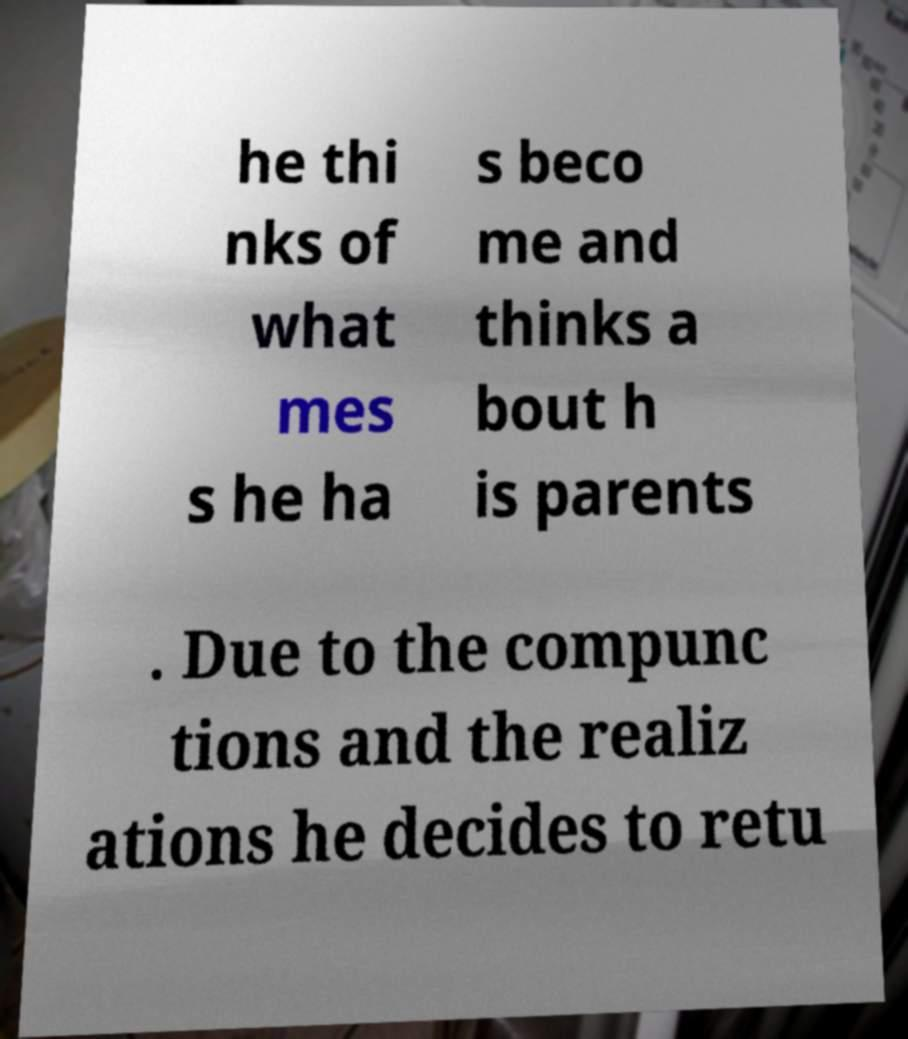Can you accurately transcribe the text from the provided image for me? he thi nks of what mes s he ha s beco me and thinks a bout h is parents . Due to the compunc tions and the realiz ations he decides to retu 